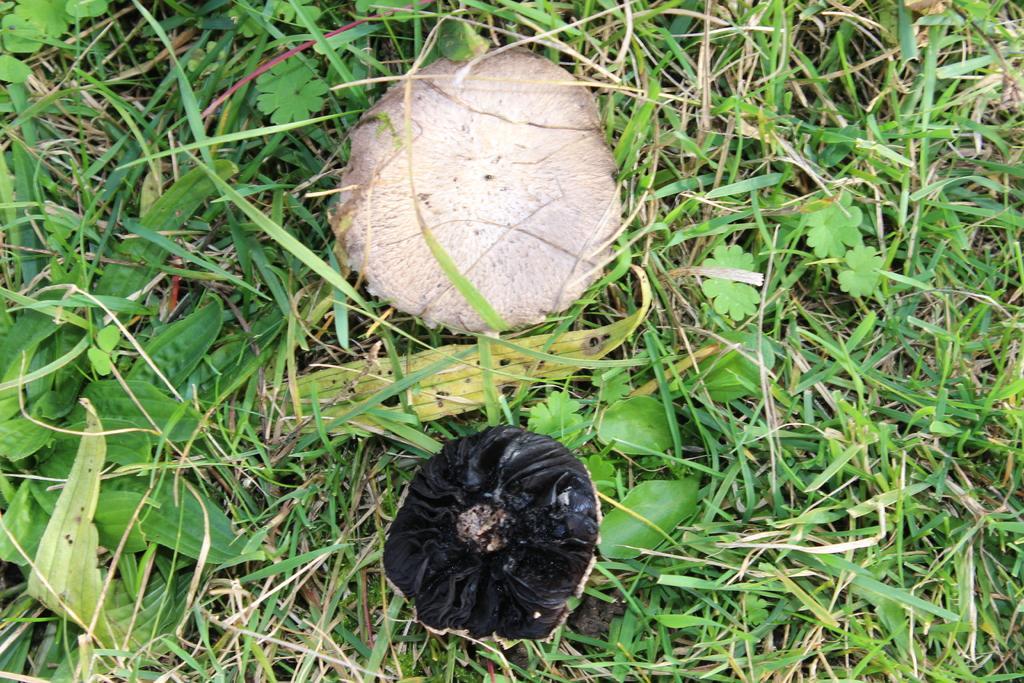Can you describe this image briefly? In this image we can see mushrooms, grass and the plants. 